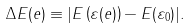Convert formula to latex. <formula><loc_0><loc_0><loc_500><loc_500>\Delta E ( e ) \equiv | E \left ( \varepsilon ( e ) \right ) - E ( \varepsilon _ { 0 } ) | .</formula> 